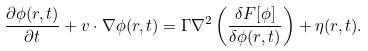<formula> <loc_0><loc_0><loc_500><loc_500>\frac { \partial \phi ( r , t ) } { \partial t } + v \cdot \nabla \phi ( r , t ) = \Gamma \nabla ^ { 2 } \left ( \frac { \delta F [ \phi ] } { \delta \phi ( r , t ) } \right ) + \eta ( r , t ) .</formula> 